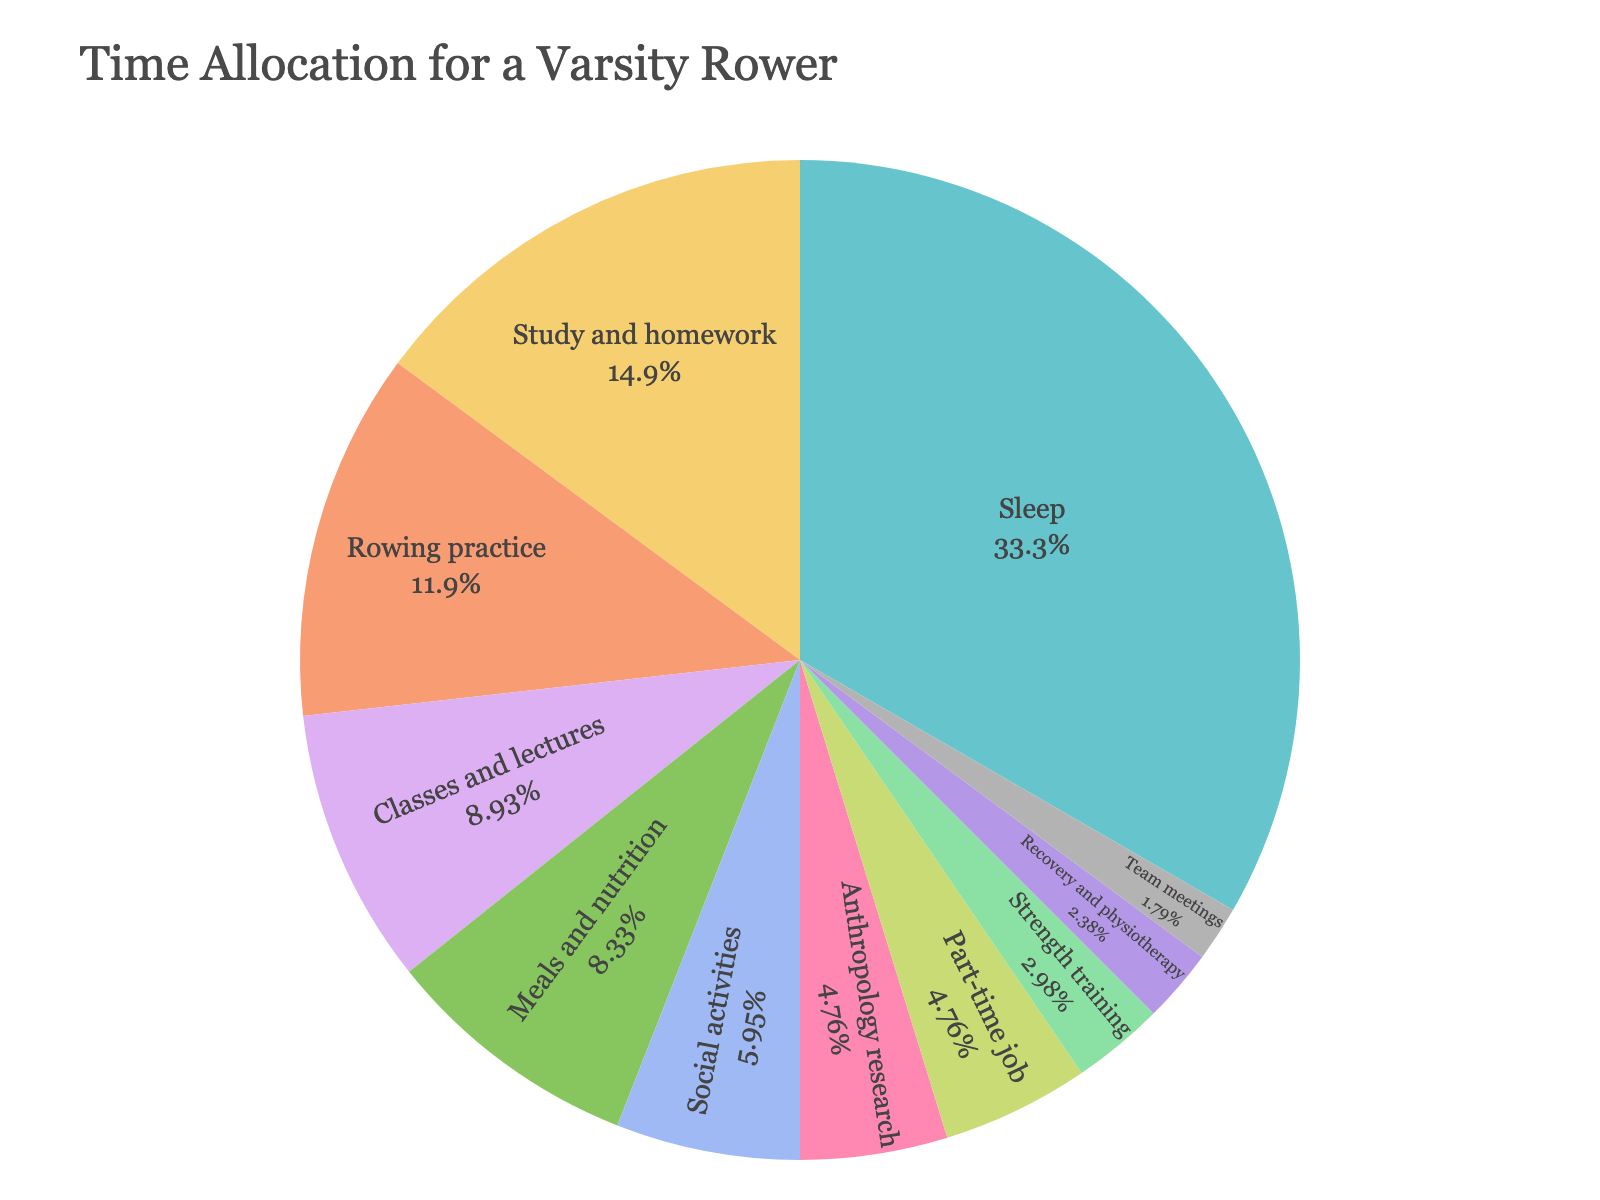Which activity takes up the most time? Identify the segment with the largest slice. The "Sleep" segment is the largest.
Answer: Sleep How many more hours are spent on study and homework compared to team meetings? Subtract the hours for team meetings from the hours for study and homework. 25 - 3 = 22
Answer: 22 What percentage of the total weekly time is spent on rowing practice and strength training combined? First, add the hours for rowing practice and strength training: 20 + 5 = 25. Then, divide by the total hours (168) and multiply by 100. (25/168) * 100 ≈ 14.88%
Answer: 14.88% Which activity takes up a smaller percentage of time: social activities or meals and nutrition? Compare the sizes of the slices labeled "Social activities" and "Meals and nutrition." The slice for social activities is smaller than the slice for meals and nutrition.
Answer: Social activities What is the visual difference between the slices for sleep and anthropology research? Compare the sizes of the slices. The slice for sleep is much larger than the slice for anthropology research.
Answer: The sleep slice is much larger How many hours are spent on activities directly related to rowing (rowing practice, team meetings, strength training, and recovery and physiotherapy)? Sum the hours for rowing practice, team meetings, strength training, and recovery and physiotherapy: 20 + 3 + 5 + 4 = 32
Answer: 32 Which takes up a larger proportion of time: meals and nutrition or classes and lectures? Compare the sizes of the slices labeled "Meals and nutrition" and "Classes and lectures". The slice for classes and lectures is larger.
Answer: Classes and lectures What is the sum of time spent on academic-related activities (classes and lectures, study and homework, and anthropology research)? Sum the hours for classes and lectures, study and homework, and anthropology research: 15 + 25 + 8 = 48
Answer: 48 What color represents the category "Recovery and physiotherapy"? Visually locate the segment labeled "Recovery and physiotherapy" and identify its color.
Answer: Light blue (or the color shown in your version) Is the time spent on sleep more than double the time spent on rowing practice? Compare twice the hours for rowing practice with the hours for sleep: 2 * 20 = 40. Since 56 > 40, the time spent on sleep is more than double the time spent on rowing practice.
Answer: Yes 